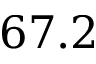<formula> <loc_0><loc_0><loc_500><loc_500>6 7 . 2</formula> 